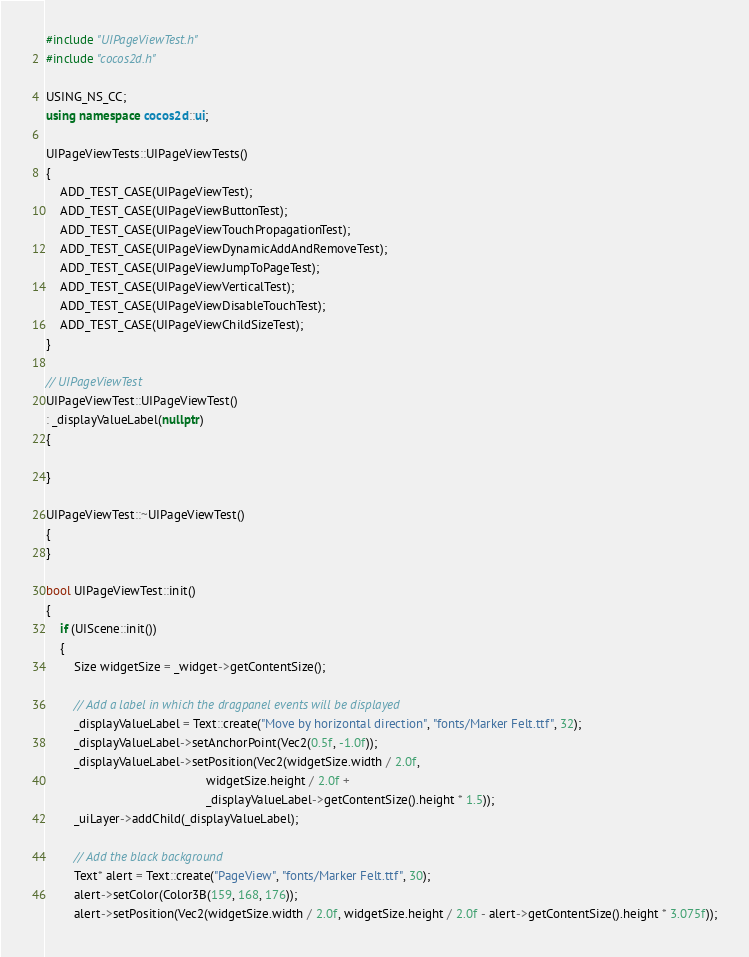<code> <loc_0><loc_0><loc_500><loc_500><_C++_>#include "UIPageViewTest.h"
#include "cocos2d.h"

USING_NS_CC;
using namespace cocos2d::ui;

UIPageViewTests::UIPageViewTests()
{
    ADD_TEST_CASE(UIPageViewTest);
    ADD_TEST_CASE(UIPageViewButtonTest);
    ADD_TEST_CASE(UIPageViewTouchPropagationTest);
    ADD_TEST_CASE(UIPageViewDynamicAddAndRemoveTest);
    ADD_TEST_CASE(UIPageViewJumpToPageTest);
    ADD_TEST_CASE(UIPageViewVerticalTest);
    ADD_TEST_CASE(UIPageViewDisableTouchTest);
    ADD_TEST_CASE(UIPageViewChildSizeTest);
}

// UIPageViewTest
UIPageViewTest::UIPageViewTest()
: _displayValueLabel(nullptr)
{
    
}

UIPageViewTest::~UIPageViewTest()
{
}

bool UIPageViewTest::init()
{
    if (UIScene::init())
    {
        Size widgetSize = _widget->getContentSize();
        
        // Add a label in which the dragpanel events will be displayed
        _displayValueLabel = Text::create("Move by horizontal direction", "fonts/Marker Felt.ttf", 32);
        _displayValueLabel->setAnchorPoint(Vec2(0.5f, -1.0f));
        _displayValueLabel->setPosition(Vec2(widgetSize.width / 2.0f,
                                              widgetSize.height / 2.0f +
                                              _displayValueLabel->getContentSize().height * 1.5));
        _uiLayer->addChild(_displayValueLabel);
        
        // Add the black background
        Text* alert = Text::create("PageView", "fonts/Marker Felt.ttf", 30);
        alert->setColor(Color3B(159, 168, 176));
        alert->setPosition(Vec2(widgetSize.width / 2.0f, widgetSize.height / 2.0f - alert->getContentSize().height * 3.075f));</code> 